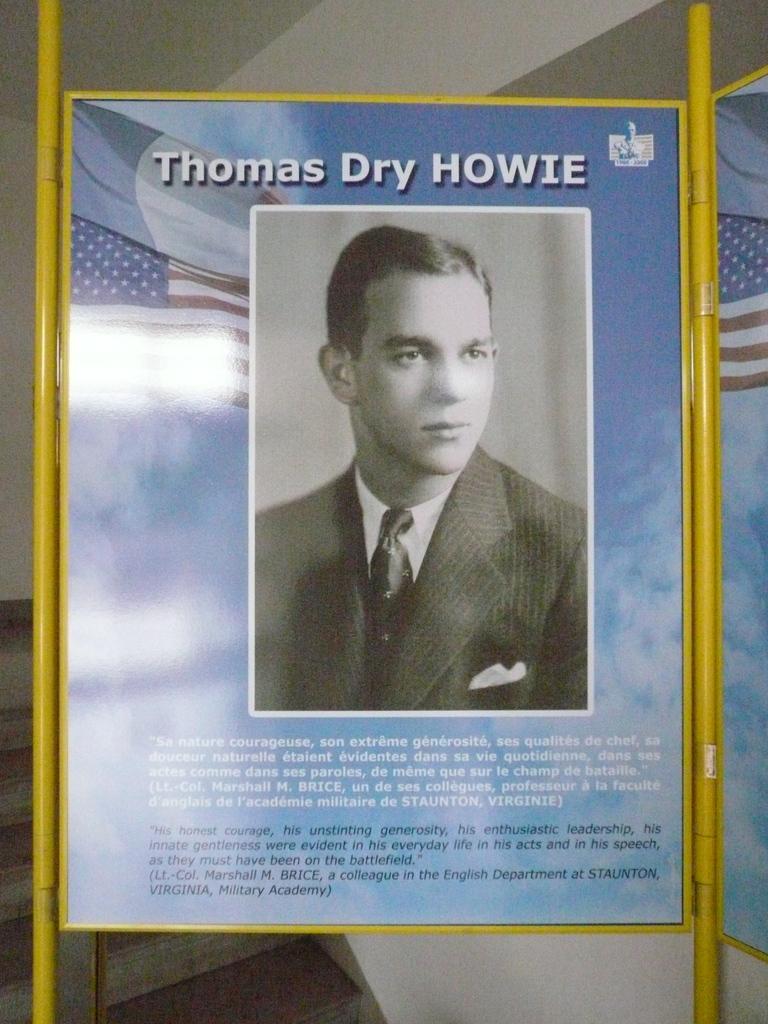Where was marshall brice from?
Give a very brief answer. Staunton, virginia. 